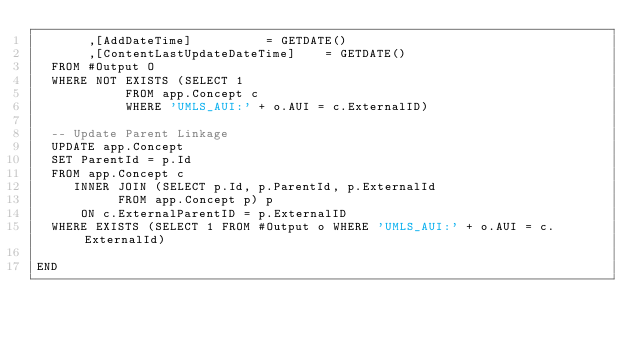Convert code to text. <code><loc_0><loc_0><loc_500><loc_500><_SQL_>       ,[AddDateTime]				   = GETDATE()
       ,[ContentLastUpdateDateTime]    = GETDATE()
	FROM #Output O
	WHERE NOT EXISTS (SELECT 1
					  FROM app.Concept c
					  WHERE 'UMLS_AUI:' + o.AUI = c.ExternalID)

	-- Update Parent Linkage
	UPDATE app.Concept
	SET ParentId = p.Id
	FROM app.Concept c
		 INNER JOIN (SELECT p.Id, p.ParentId, p.ExternalId
					 FROM app.Concept p) p 
			ON c.ExternalParentID = p.ExternalID
	WHERE EXISTS (SELECT 1 FROM #Output o WHERE 'UMLS_AUI:' + o.AUI = c.ExternalId)

END
</code> 